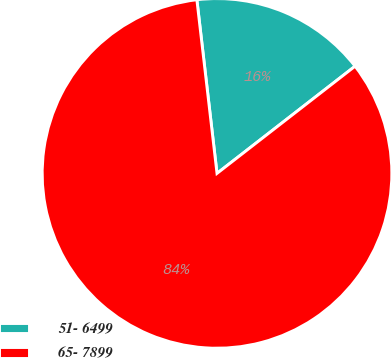Convert chart. <chart><loc_0><loc_0><loc_500><loc_500><pie_chart><fcel>51- 6499<fcel>65- 7899<nl><fcel>16.33%<fcel>83.67%<nl></chart> 